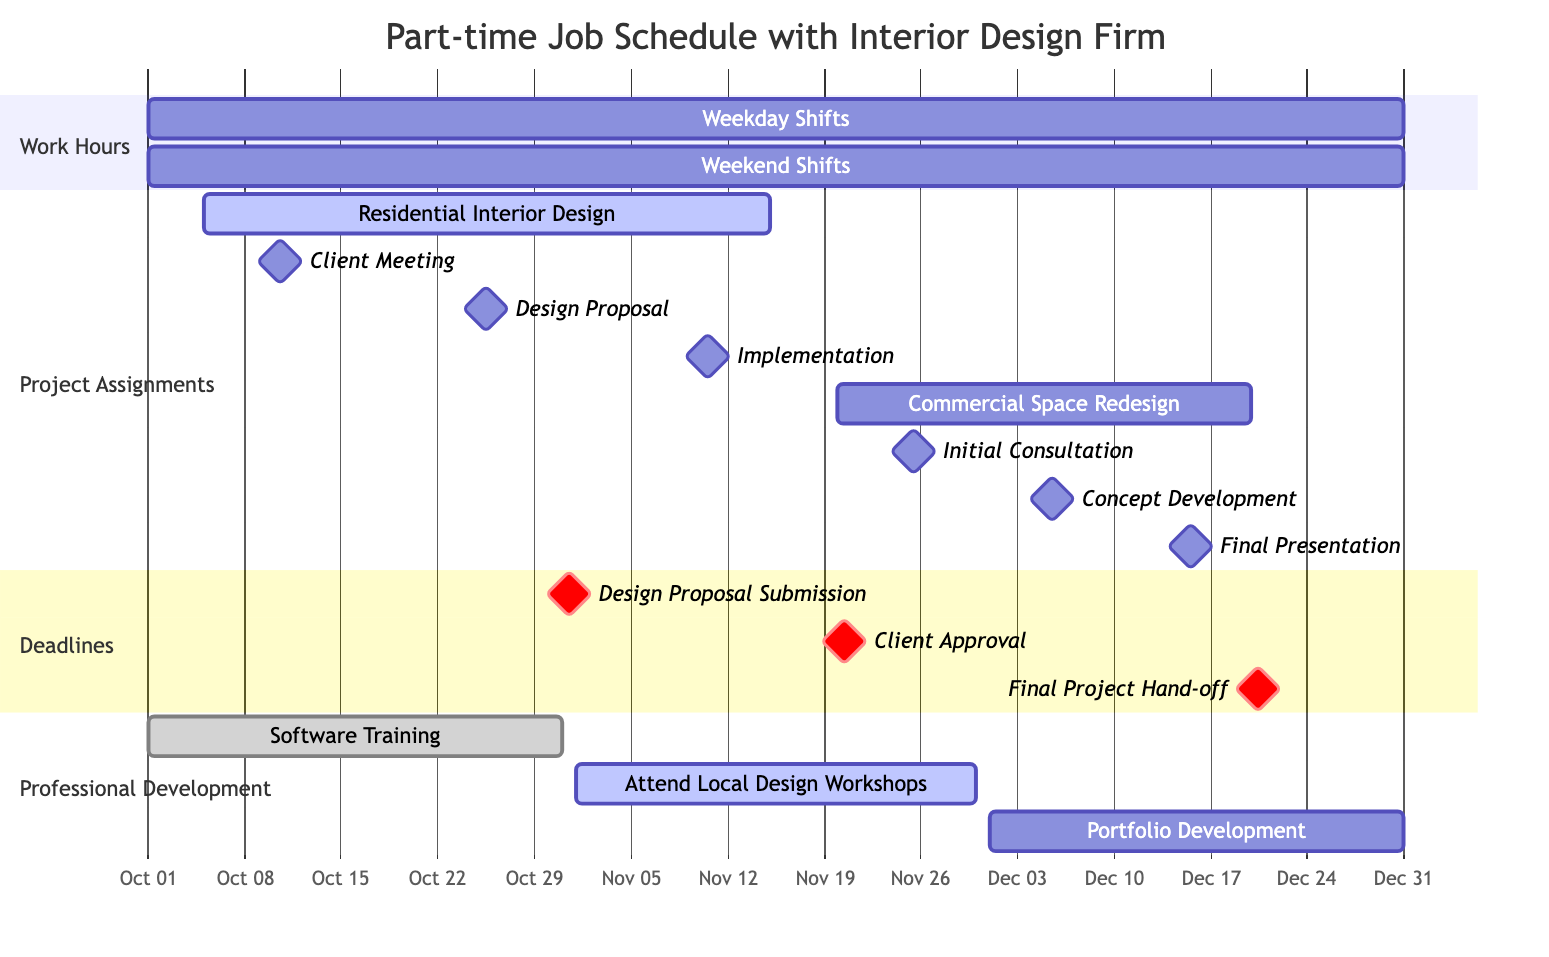What is the duration of the Weekday Shifts? The Weekday Shifts start on October 1, 2023, and end on December 31, 2023. This gives a total duration of approximately three months.
Answer: three months When does the Design Proposal need to be submitted? The Design Proposal Submission is a critical milestone marked for October 31, 2023. Therefore, it needs to be submitted on this specific date.
Answer: October 31, 2023 How many professional development tasks are there in total? There are three professional development tasks listed: Software Training, Attend Local Design Workshops, and Portfolio Development. This can be counted directly from the details under the "Professional Development" section of the Gantt Chart.
Answer: three Which project has its initial consultation scheduled first? The initial consultation for the Commercial Space Redesign project is scheduled for November 25, 2023, which is after the Residential Interior Design project. Hence, it occurs first in sequence compared to the projects listed.
Answer: Commercial Space Redesign What is the last deadline in the schedule? The last deadline is the Final Project Hand-off, scheduled for December 20, 2023. This can be pinpointed as the last milestone in the Deadlines section at the timeline's end.
Answer: December 20, 2023 How long does the Software Training last? The Software Training begins on October 1, 2023, and ends on October 31, 2023. This indicates that the training lasts for the entire month of October.
Answer: one month What is the overlap between the Residential Interior Design and the Commercial Space Redesign projects? The overlap occurs from November 20, 2023, when the Commercial Space Redesign begins, and ends with the conclusion of the Residential Interior Design on November 15, 2023. This shows that there is no overlap since the Commercial Space starts after the Residential ends.
Answer: none What is the total number of milestones for the Residential Interior Design project? The Residential Interior Design project has three milestones: Client Meeting, Design Proposal, and Implementation. This shows the specific checkpoints marked within the project's timeline.
Answer: three 